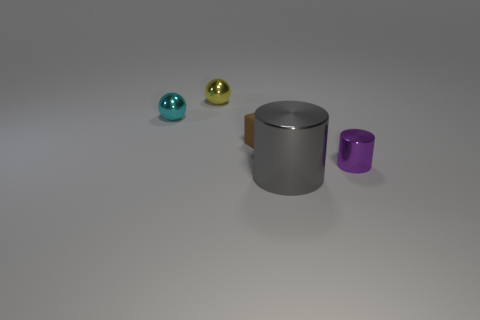Is the number of objects on the left side of the small purple shiny object greater than the number of metallic objects?
Offer a very short reply. No. Are there any large cylinders of the same color as the big object?
Offer a terse response. No. What color is the cylinder that is the same size as the yellow sphere?
Offer a very short reply. Purple. There is a shiny thing that is behind the cyan ball; what number of cyan spheres are in front of it?
Provide a succinct answer. 1. What number of things are things in front of the small cyan sphere or yellow blocks?
Your answer should be very brief. 3. How many tiny cylinders have the same material as the small yellow object?
Give a very brief answer. 1. Is the number of rubber cubes on the right side of the large shiny cylinder the same as the number of metal cylinders?
Ensure brevity in your answer.  No. There is a shiny cylinder to the right of the large shiny object; what is its size?
Give a very brief answer. Small. What number of small things are shiny objects or cylinders?
Offer a terse response. 3. The other tiny shiny thing that is the same shape as the cyan thing is what color?
Keep it short and to the point. Yellow. 